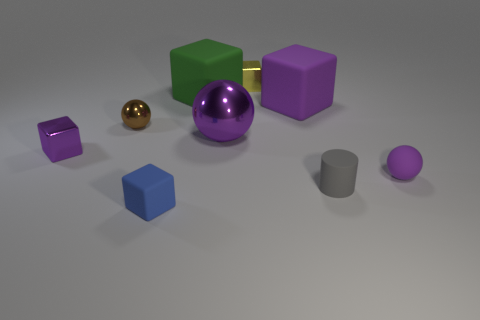Subtract all small purple metallic blocks. How many blocks are left? 4 Subtract all blue cubes. How many cubes are left? 4 Subtract all blue cubes. Subtract all cyan cylinders. How many cubes are left? 4 Add 1 purple rubber blocks. How many objects exist? 10 Subtract all cubes. How many objects are left? 4 Subtract all big green blocks. Subtract all green matte cylinders. How many objects are left? 8 Add 5 large purple matte cubes. How many large purple matte cubes are left? 6 Add 7 big purple metal balls. How many big purple metal balls exist? 8 Subtract 2 purple spheres. How many objects are left? 7 